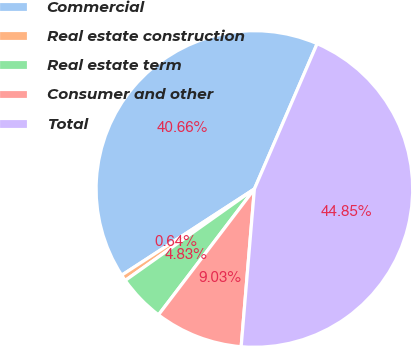Convert chart to OTSL. <chart><loc_0><loc_0><loc_500><loc_500><pie_chart><fcel>Commercial<fcel>Real estate construction<fcel>Real estate term<fcel>Consumer and other<fcel>Total<nl><fcel>40.66%<fcel>0.64%<fcel>4.83%<fcel>9.03%<fcel>44.85%<nl></chart> 